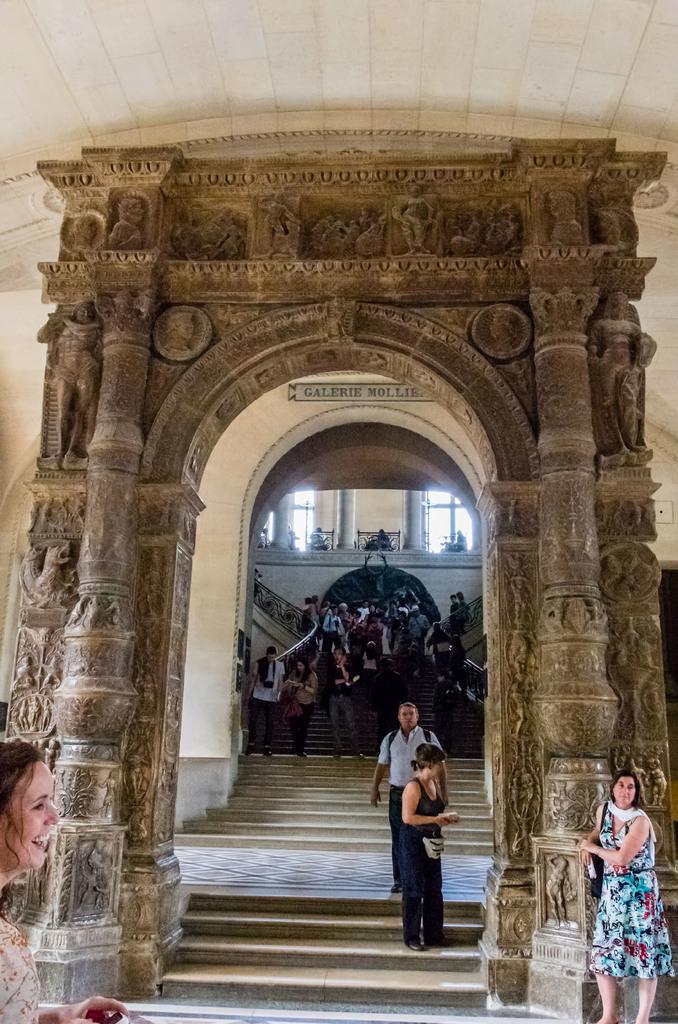In one or two sentences, can you explain what this image depicts? In this picture I can see there is a sculpture and there is a woman standing here at the pillar and there are two other people standing on the stairs here. There is a woman walking here and smiling and in the backdrop there are stairs and there is a wall and windows. 